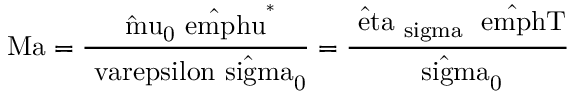Convert formula to latex. <formula><loc_0><loc_0><loc_500><loc_500>M a = \frac { \hat { \ m u } _ { 0 } \hat { \ e m p h { u } } ^ { * } } { \ v a r e p s i l o n \hat { \ s i g m a } _ { 0 } } = \frac { \hat { \ e t a } _ { \ s i g m a } \Delta \hat { \ e m p h { T } } } { \hat { \ s i g m a } _ { 0 } }</formula> 